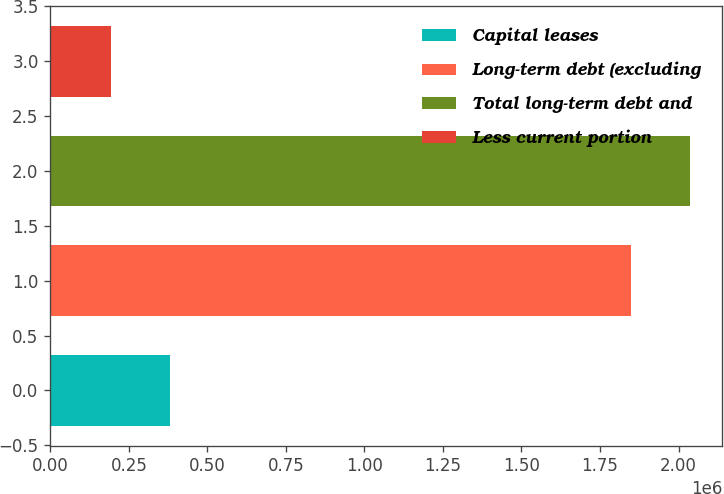Convert chart. <chart><loc_0><loc_0><loc_500><loc_500><bar_chart><fcel>Capital leases<fcel>Long-term debt (excluding<fcel>Total long-term debt and<fcel>Less current portion<nl><fcel>382615<fcel>1.84698e+06<fcel>2.03687e+06<fcel>192725<nl></chart> 